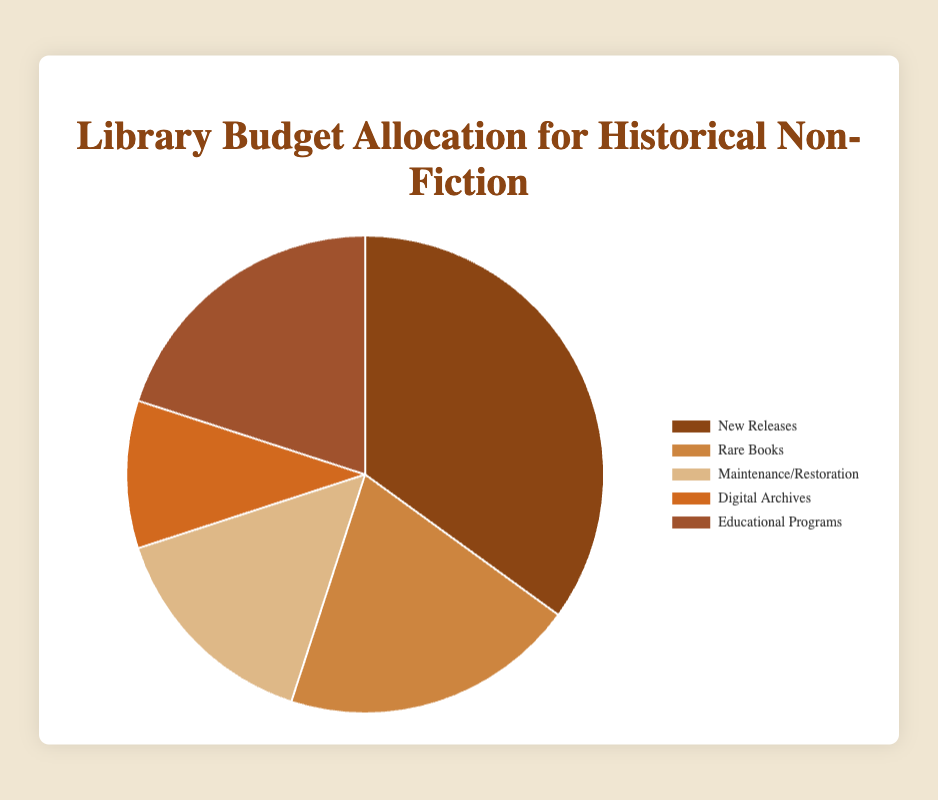What percentage of the library's budget is allocated to New Releases and Educational Programs combined? To find the total percentage allocated to both categories, add the allocation percentages of New Releases (35%) and Educational Programs (20%). So, the combined allocation is 35% + 20% = 55%.
Answer: 55% Which category has a larger budget allocation: Rare Books or Maintenance/Restoration? Comparing the allocation percentages: Rare Books has 20% and Maintenance/Restoration has 15%. Therefore, Rare Books has a larger budget allocation.
Answer: Rare Books What is the difference in budget allocation between Digital Archives and Maintenance/Restoration? Subtract the allocation percentage of Digital Archives (10%) from Maintenance/Restoration (15%). So, the difference is 15% - 10% = 5%.
Answer: 5% Which category has the smallest budget allocation, and what is it? Among the given categories, Digital Archives has the smallest allocation with 10%.
Answer: Digital Archives (10%) How many categories have a budget allocation of at least 20%? The categories with allocations of at least 20% are New Releases (35%), Rare Books (20%), and Educational Programs (20%). So, there are 3 categories.
Answer: 3 What is the average budget allocation percentage across all categories? First, sum all the percentages: 35% + 20% + 15% + 10% + 20% = 100%. As there are 5 categories, the average allocation is 100% / 5 = 20%.
Answer: 20% If the library decided to increase the allocation for Digital Archives by 5%, what would the new allocation be? Add the additional 5% to the current allocation of Digital Archives (10%). The new allocation would be 10% + 5% = 15%.
Answer: 15% Visually, which category is represented by the darkest color on the pie chart? The pie chart describes New Releases with the darkest color.
Answer: New Releases What is the total percentage allocated to categories other than New Releases? Subtract the New Releases percentage (35%) from 100%. So, the total for other categories is 100% - 35% = 65%.
Answer: 65% Which category shares the same percentage allocation as Educational Programs? Both Rare Books and Educational Programs have an allocation of 20%.
Answer: Rare Books 